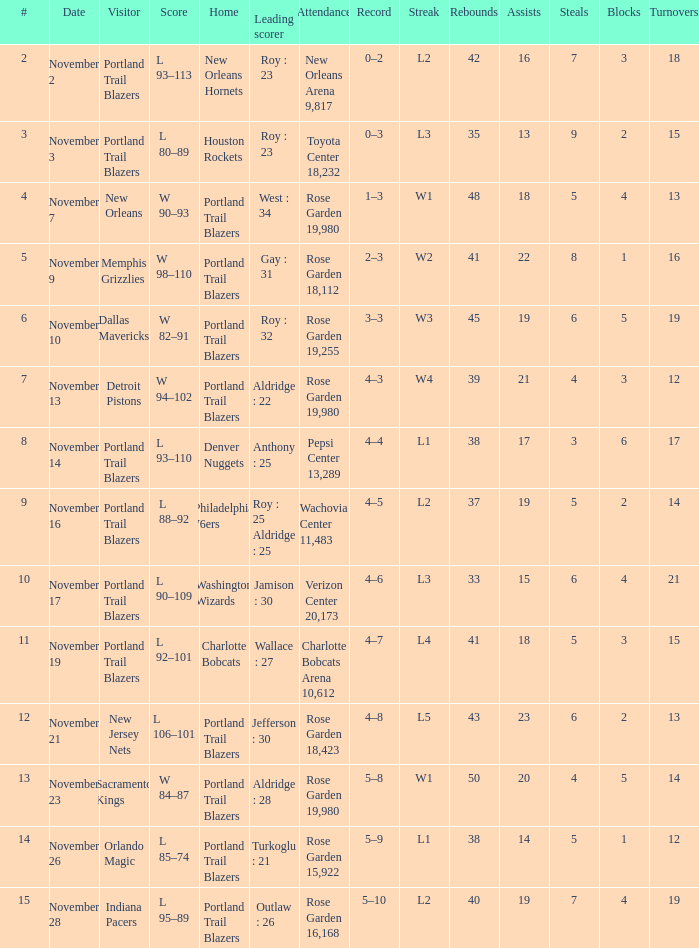What is the total number of record where streak is l2 and leading scorer is roy : 23 1.0. 